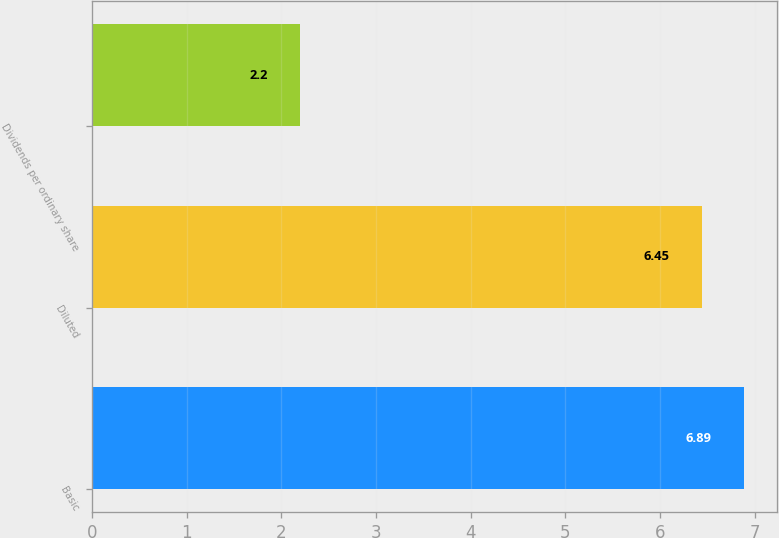Convert chart to OTSL. <chart><loc_0><loc_0><loc_500><loc_500><bar_chart><fcel>Basic<fcel>Diluted<fcel>Dividends per ordinary share<nl><fcel>6.89<fcel>6.45<fcel>2.2<nl></chart> 